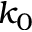<formula> <loc_0><loc_0><loc_500><loc_500>k _ { 0 }</formula> 